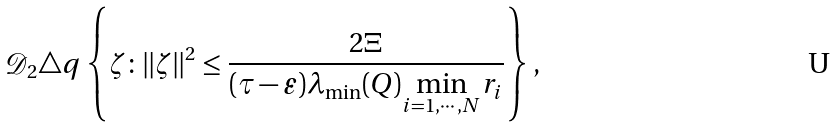<formula> <loc_0><loc_0><loc_500><loc_500>\mathcal { D } _ { 2 } \triangle q \left \{ \zeta \colon \| \zeta \| ^ { 2 } \leq \frac { 2 \Xi } { ( \tau - \varepsilon ) \lambda _ { \min } ( Q ) \underset { i = 1 , \cdots , N } { \min } r _ { i } } \right \} ,</formula> 